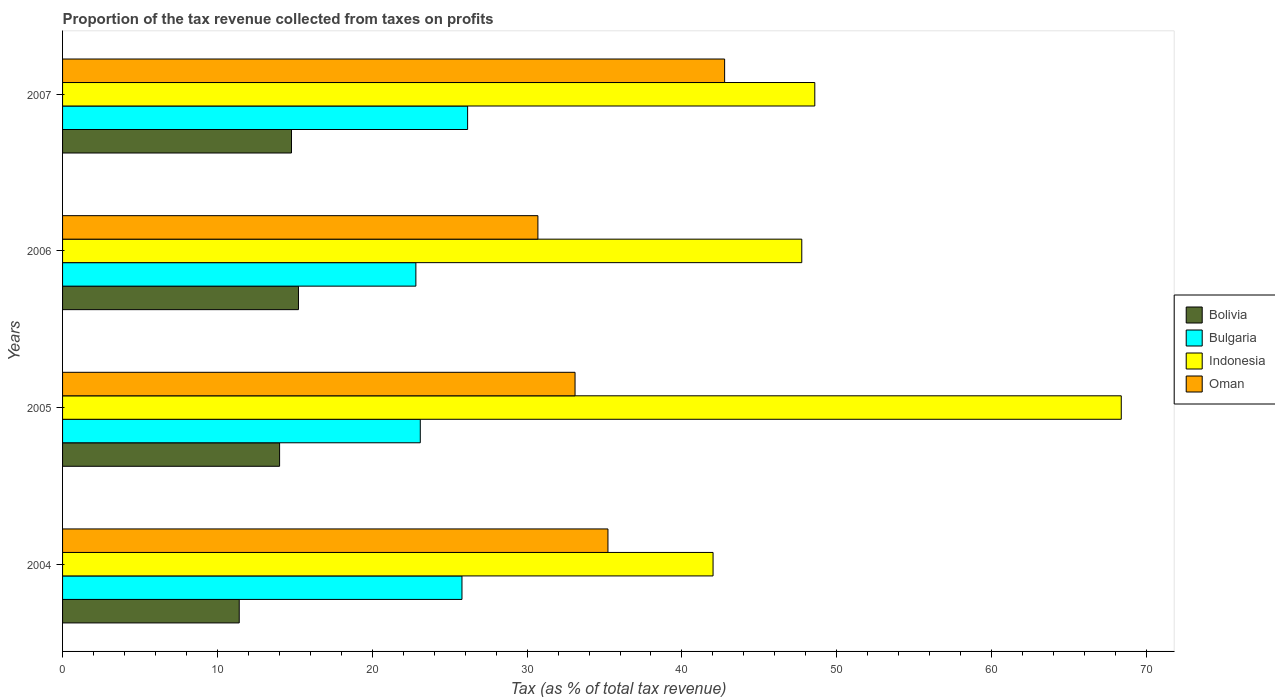How many different coloured bars are there?
Provide a short and direct response. 4. How many groups of bars are there?
Provide a succinct answer. 4. Are the number of bars per tick equal to the number of legend labels?
Ensure brevity in your answer.  Yes. Are the number of bars on each tick of the Y-axis equal?
Offer a terse response. Yes. What is the label of the 4th group of bars from the top?
Keep it short and to the point. 2004. In how many cases, is the number of bars for a given year not equal to the number of legend labels?
Ensure brevity in your answer.  0. What is the proportion of the tax revenue collected in Bolivia in 2006?
Offer a very short reply. 15.23. Across all years, what is the maximum proportion of the tax revenue collected in Oman?
Offer a very short reply. 42.76. Across all years, what is the minimum proportion of the tax revenue collected in Oman?
Your response must be concise. 30.7. In which year was the proportion of the tax revenue collected in Bulgaria maximum?
Provide a succinct answer. 2007. What is the total proportion of the tax revenue collected in Bulgaria in the graph?
Provide a short and direct response. 97.87. What is the difference between the proportion of the tax revenue collected in Bulgaria in 2004 and that in 2007?
Your answer should be compact. -0.36. What is the difference between the proportion of the tax revenue collected in Bulgaria in 2006 and the proportion of the tax revenue collected in Oman in 2005?
Keep it short and to the point. -10.28. What is the average proportion of the tax revenue collected in Bolivia per year?
Keep it short and to the point. 13.86. In the year 2007, what is the difference between the proportion of the tax revenue collected in Oman and proportion of the tax revenue collected in Bulgaria?
Ensure brevity in your answer.  16.6. In how many years, is the proportion of the tax revenue collected in Bolivia greater than 60 %?
Keep it short and to the point. 0. What is the ratio of the proportion of the tax revenue collected in Bolivia in 2005 to that in 2007?
Provide a succinct answer. 0.95. Is the difference between the proportion of the tax revenue collected in Oman in 2004 and 2006 greater than the difference between the proportion of the tax revenue collected in Bulgaria in 2004 and 2006?
Give a very brief answer. Yes. What is the difference between the highest and the second highest proportion of the tax revenue collected in Oman?
Offer a very short reply. 7.53. What is the difference between the highest and the lowest proportion of the tax revenue collected in Indonesia?
Offer a terse response. 26.36. Is the sum of the proportion of the tax revenue collected in Indonesia in 2004 and 2007 greater than the maximum proportion of the tax revenue collected in Bulgaria across all years?
Your response must be concise. Yes. What does the 1st bar from the top in 2005 represents?
Offer a terse response. Oman. What does the 3rd bar from the bottom in 2006 represents?
Offer a terse response. Indonesia. Are all the bars in the graph horizontal?
Provide a short and direct response. Yes. How many years are there in the graph?
Provide a succinct answer. 4. Does the graph contain any zero values?
Your answer should be compact. No. How many legend labels are there?
Make the answer very short. 4. What is the title of the graph?
Offer a terse response. Proportion of the tax revenue collected from taxes on profits. Does "Bangladesh" appear as one of the legend labels in the graph?
Ensure brevity in your answer.  No. What is the label or title of the X-axis?
Ensure brevity in your answer.  Tax (as % of total tax revenue). What is the label or title of the Y-axis?
Ensure brevity in your answer.  Years. What is the Tax (as % of total tax revenue) in Bolivia in 2004?
Keep it short and to the point. 11.41. What is the Tax (as % of total tax revenue) of Bulgaria in 2004?
Ensure brevity in your answer.  25.79. What is the Tax (as % of total tax revenue) of Indonesia in 2004?
Make the answer very short. 42.01. What is the Tax (as % of total tax revenue) in Oman in 2004?
Ensure brevity in your answer.  35.22. What is the Tax (as % of total tax revenue) of Bolivia in 2005?
Provide a short and direct response. 14.02. What is the Tax (as % of total tax revenue) of Bulgaria in 2005?
Your answer should be very brief. 23.1. What is the Tax (as % of total tax revenue) in Indonesia in 2005?
Offer a terse response. 68.37. What is the Tax (as % of total tax revenue) in Oman in 2005?
Offer a terse response. 33.1. What is the Tax (as % of total tax revenue) of Bolivia in 2006?
Offer a very short reply. 15.23. What is the Tax (as % of total tax revenue) of Bulgaria in 2006?
Offer a very short reply. 22.82. What is the Tax (as % of total tax revenue) in Indonesia in 2006?
Provide a succinct answer. 47.74. What is the Tax (as % of total tax revenue) of Oman in 2006?
Your response must be concise. 30.7. What is the Tax (as % of total tax revenue) of Bolivia in 2007?
Provide a short and direct response. 14.78. What is the Tax (as % of total tax revenue) in Bulgaria in 2007?
Keep it short and to the point. 26.16. What is the Tax (as % of total tax revenue) of Indonesia in 2007?
Offer a terse response. 48.58. What is the Tax (as % of total tax revenue) in Oman in 2007?
Keep it short and to the point. 42.76. Across all years, what is the maximum Tax (as % of total tax revenue) in Bolivia?
Keep it short and to the point. 15.23. Across all years, what is the maximum Tax (as % of total tax revenue) in Bulgaria?
Your answer should be very brief. 26.16. Across all years, what is the maximum Tax (as % of total tax revenue) of Indonesia?
Keep it short and to the point. 68.37. Across all years, what is the maximum Tax (as % of total tax revenue) in Oman?
Provide a succinct answer. 42.76. Across all years, what is the minimum Tax (as % of total tax revenue) in Bolivia?
Keep it short and to the point. 11.41. Across all years, what is the minimum Tax (as % of total tax revenue) of Bulgaria?
Make the answer very short. 22.82. Across all years, what is the minimum Tax (as % of total tax revenue) of Indonesia?
Offer a terse response. 42.01. Across all years, what is the minimum Tax (as % of total tax revenue) in Oman?
Give a very brief answer. 30.7. What is the total Tax (as % of total tax revenue) of Bolivia in the graph?
Provide a short and direct response. 55.44. What is the total Tax (as % of total tax revenue) in Bulgaria in the graph?
Provide a short and direct response. 97.87. What is the total Tax (as % of total tax revenue) in Indonesia in the graph?
Your answer should be very brief. 206.7. What is the total Tax (as % of total tax revenue) of Oman in the graph?
Ensure brevity in your answer.  141.77. What is the difference between the Tax (as % of total tax revenue) of Bolivia in 2004 and that in 2005?
Your response must be concise. -2.61. What is the difference between the Tax (as % of total tax revenue) in Bulgaria in 2004 and that in 2005?
Your response must be concise. 2.69. What is the difference between the Tax (as % of total tax revenue) of Indonesia in 2004 and that in 2005?
Offer a very short reply. -26.36. What is the difference between the Tax (as % of total tax revenue) in Oman in 2004 and that in 2005?
Provide a succinct answer. 2.13. What is the difference between the Tax (as % of total tax revenue) of Bolivia in 2004 and that in 2006?
Your answer should be compact. -3.83. What is the difference between the Tax (as % of total tax revenue) in Bulgaria in 2004 and that in 2006?
Provide a succinct answer. 2.98. What is the difference between the Tax (as % of total tax revenue) in Indonesia in 2004 and that in 2006?
Your answer should be compact. -5.73. What is the difference between the Tax (as % of total tax revenue) of Oman in 2004 and that in 2006?
Make the answer very short. 4.52. What is the difference between the Tax (as % of total tax revenue) in Bolivia in 2004 and that in 2007?
Provide a succinct answer. -3.37. What is the difference between the Tax (as % of total tax revenue) in Bulgaria in 2004 and that in 2007?
Provide a succinct answer. -0.36. What is the difference between the Tax (as % of total tax revenue) of Indonesia in 2004 and that in 2007?
Your answer should be compact. -6.57. What is the difference between the Tax (as % of total tax revenue) in Oman in 2004 and that in 2007?
Give a very brief answer. -7.53. What is the difference between the Tax (as % of total tax revenue) in Bolivia in 2005 and that in 2006?
Give a very brief answer. -1.22. What is the difference between the Tax (as % of total tax revenue) of Bulgaria in 2005 and that in 2006?
Give a very brief answer. 0.28. What is the difference between the Tax (as % of total tax revenue) in Indonesia in 2005 and that in 2006?
Provide a short and direct response. 20.63. What is the difference between the Tax (as % of total tax revenue) of Oman in 2005 and that in 2006?
Your response must be concise. 2.4. What is the difference between the Tax (as % of total tax revenue) of Bolivia in 2005 and that in 2007?
Offer a very short reply. -0.77. What is the difference between the Tax (as % of total tax revenue) in Bulgaria in 2005 and that in 2007?
Make the answer very short. -3.06. What is the difference between the Tax (as % of total tax revenue) in Indonesia in 2005 and that in 2007?
Provide a short and direct response. 19.79. What is the difference between the Tax (as % of total tax revenue) of Oman in 2005 and that in 2007?
Provide a succinct answer. -9.66. What is the difference between the Tax (as % of total tax revenue) in Bolivia in 2006 and that in 2007?
Make the answer very short. 0.45. What is the difference between the Tax (as % of total tax revenue) in Bulgaria in 2006 and that in 2007?
Your response must be concise. -3.34. What is the difference between the Tax (as % of total tax revenue) of Indonesia in 2006 and that in 2007?
Your answer should be compact. -0.84. What is the difference between the Tax (as % of total tax revenue) in Oman in 2006 and that in 2007?
Offer a very short reply. -12.06. What is the difference between the Tax (as % of total tax revenue) in Bolivia in 2004 and the Tax (as % of total tax revenue) in Bulgaria in 2005?
Your response must be concise. -11.69. What is the difference between the Tax (as % of total tax revenue) in Bolivia in 2004 and the Tax (as % of total tax revenue) in Indonesia in 2005?
Your answer should be compact. -56.96. What is the difference between the Tax (as % of total tax revenue) in Bolivia in 2004 and the Tax (as % of total tax revenue) in Oman in 2005?
Keep it short and to the point. -21.69. What is the difference between the Tax (as % of total tax revenue) of Bulgaria in 2004 and the Tax (as % of total tax revenue) of Indonesia in 2005?
Make the answer very short. -42.58. What is the difference between the Tax (as % of total tax revenue) in Bulgaria in 2004 and the Tax (as % of total tax revenue) in Oman in 2005?
Give a very brief answer. -7.3. What is the difference between the Tax (as % of total tax revenue) in Indonesia in 2004 and the Tax (as % of total tax revenue) in Oman in 2005?
Give a very brief answer. 8.91. What is the difference between the Tax (as % of total tax revenue) in Bolivia in 2004 and the Tax (as % of total tax revenue) in Bulgaria in 2006?
Ensure brevity in your answer.  -11.41. What is the difference between the Tax (as % of total tax revenue) in Bolivia in 2004 and the Tax (as % of total tax revenue) in Indonesia in 2006?
Offer a terse response. -36.33. What is the difference between the Tax (as % of total tax revenue) in Bolivia in 2004 and the Tax (as % of total tax revenue) in Oman in 2006?
Ensure brevity in your answer.  -19.29. What is the difference between the Tax (as % of total tax revenue) of Bulgaria in 2004 and the Tax (as % of total tax revenue) of Indonesia in 2006?
Make the answer very short. -21.95. What is the difference between the Tax (as % of total tax revenue) of Bulgaria in 2004 and the Tax (as % of total tax revenue) of Oman in 2006?
Your answer should be compact. -4.9. What is the difference between the Tax (as % of total tax revenue) in Indonesia in 2004 and the Tax (as % of total tax revenue) in Oman in 2006?
Your answer should be compact. 11.31. What is the difference between the Tax (as % of total tax revenue) in Bolivia in 2004 and the Tax (as % of total tax revenue) in Bulgaria in 2007?
Make the answer very short. -14.75. What is the difference between the Tax (as % of total tax revenue) of Bolivia in 2004 and the Tax (as % of total tax revenue) of Indonesia in 2007?
Provide a short and direct response. -37.17. What is the difference between the Tax (as % of total tax revenue) of Bolivia in 2004 and the Tax (as % of total tax revenue) of Oman in 2007?
Ensure brevity in your answer.  -31.35. What is the difference between the Tax (as % of total tax revenue) in Bulgaria in 2004 and the Tax (as % of total tax revenue) in Indonesia in 2007?
Give a very brief answer. -22.79. What is the difference between the Tax (as % of total tax revenue) of Bulgaria in 2004 and the Tax (as % of total tax revenue) of Oman in 2007?
Your response must be concise. -16.96. What is the difference between the Tax (as % of total tax revenue) in Indonesia in 2004 and the Tax (as % of total tax revenue) in Oman in 2007?
Provide a succinct answer. -0.75. What is the difference between the Tax (as % of total tax revenue) of Bolivia in 2005 and the Tax (as % of total tax revenue) of Bulgaria in 2006?
Your response must be concise. -8.8. What is the difference between the Tax (as % of total tax revenue) in Bolivia in 2005 and the Tax (as % of total tax revenue) in Indonesia in 2006?
Your answer should be very brief. -33.72. What is the difference between the Tax (as % of total tax revenue) in Bolivia in 2005 and the Tax (as % of total tax revenue) in Oman in 2006?
Keep it short and to the point. -16.68. What is the difference between the Tax (as % of total tax revenue) of Bulgaria in 2005 and the Tax (as % of total tax revenue) of Indonesia in 2006?
Make the answer very short. -24.64. What is the difference between the Tax (as % of total tax revenue) of Bulgaria in 2005 and the Tax (as % of total tax revenue) of Oman in 2006?
Ensure brevity in your answer.  -7.6. What is the difference between the Tax (as % of total tax revenue) of Indonesia in 2005 and the Tax (as % of total tax revenue) of Oman in 2006?
Your answer should be very brief. 37.67. What is the difference between the Tax (as % of total tax revenue) of Bolivia in 2005 and the Tax (as % of total tax revenue) of Bulgaria in 2007?
Give a very brief answer. -12.14. What is the difference between the Tax (as % of total tax revenue) in Bolivia in 2005 and the Tax (as % of total tax revenue) in Indonesia in 2007?
Give a very brief answer. -34.56. What is the difference between the Tax (as % of total tax revenue) in Bolivia in 2005 and the Tax (as % of total tax revenue) in Oman in 2007?
Your answer should be compact. -28.74. What is the difference between the Tax (as % of total tax revenue) in Bulgaria in 2005 and the Tax (as % of total tax revenue) in Indonesia in 2007?
Give a very brief answer. -25.48. What is the difference between the Tax (as % of total tax revenue) in Bulgaria in 2005 and the Tax (as % of total tax revenue) in Oman in 2007?
Give a very brief answer. -19.65. What is the difference between the Tax (as % of total tax revenue) of Indonesia in 2005 and the Tax (as % of total tax revenue) of Oman in 2007?
Your answer should be compact. 25.61. What is the difference between the Tax (as % of total tax revenue) in Bolivia in 2006 and the Tax (as % of total tax revenue) in Bulgaria in 2007?
Your answer should be very brief. -10.92. What is the difference between the Tax (as % of total tax revenue) of Bolivia in 2006 and the Tax (as % of total tax revenue) of Indonesia in 2007?
Your response must be concise. -33.34. What is the difference between the Tax (as % of total tax revenue) of Bolivia in 2006 and the Tax (as % of total tax revenue) of Oman in 2007?
Ensure brevity in your answer.  -27.52. What is the difference between the Tax (as % of total tax revenue) of Bulgaria in 2006 and the Tax (as % of total tax revenue) of Indonesia in 2007?
Ensure brevity in your answer.  -25.76. What is the difference between the Tax (as % of total tax revenue) in Bulgaria in 2006 and the Tax (as % of total tax revenue) in Oman in 2007?
Offer a terse response. -19.94. What is the difference between the Tax (as % of total tax revenue) of Indonesia in 2006 and the Tax (as % of total tax revenue) of Oman in 2007?
Your response must be concise. 4.98. What is the average Tax (as % of total tax revenue) of Bolivia per year?
Give a very brief answer. 13.86. What is the average Tax (as % of total tax revenue) in Bulgaria per year?
Provide a succinct answer. 24.47. What is the average Tax (as % of total tax revenue) of Indonesia per year?
Offer a terse response. 51.67. What is the average Tax (as % of total tax revenue) in Oman per year?
Your answer should be compact. 35.44. In the year 2004, what is the difference between the Tax (as % of total tax revenue) in Bolivia and Tax (as % of total tax revenue) in Bulgaria?
Your response must be concise. -14.38. In the year 2004, what is the difference between the Tax (as % of total tax revenue) in Bolivia and Tax (as % of total tax revenue) in Indonesia?
Your answer should be compact. -30.6. In the year 2004, what is the difference between the Tax (as % of total tax revenue) of Bolivia and Tax (as % of total tax revenue) of Oman?
Give a very brief answer. -23.81. In the year 2004, what is the difference between the Tax (as % of total tax revenue) of Bulgaria and Tax (as % of total tax revenue) of Indonesia?
Keep it short and to the point. -16.21. In the year 2004, what is the difference between the Tax (as % of total tax revenue) of Bulgaria and Tax (as % of total tax revenue) of Oman?
Offer a very short reply. -9.43. In the year 2004, what is the difference between the Tax (as % of total tax revenue) of Indonesia and Tax (as % of total tax revenue) of Oman?
Provide a succinct answer. 6.79. In the year 2005, what is the difference between the Tax (as % of total tax revenue) of Bolivia and Tax (as % of total tax revenue) of Bulgaria?
Your answer should be compact. -9.09. In the year 2005, what is the difference between the Tax (as % of total tax revenue) in Bolivia and Tax (as % of total tax revenue) in Indonesia?
Offer a very short reply. -54.35. In the year 2005, what is the difference between the Tax (as % of total tax revenue) of Bolivia and Tax (as % of total tax revenue) of Oman?
Offer a very short reply. -19.08. In the year 2005, what is the difference between the Tax (as % of total tax revenue) in Bulgaria and Tax (as % of total tax revenue) in Indonesia?
Provide a short and direct response. -45.27. In the year 2005, what is the difference between the Tax (as % of total tax revenue) of Bulgaria and Tax (as % of total tax revenue) of Oman?
Your answer should be compact. -9.99. In the year 2005, what is the difference between the Tax (as % of total tax revenue) of Indonesia and Tax (as % of total tax revenue) of Oman?
Offer a terse response. 35.27. In the year 2006, what is the difference between the Tax (as % of total tax revenue) of Bolivia and Tax (as % of total tax revenue) of Bulgaria?
Offer a terse response. -7.58. In the year 2006, what is the difference between the Tax (as % of total tax revenue) of Bolivia and Tax (as % of total tax revenue) of Indonesia?
Your answer should be compact. -32.5. In the year 2006, what is the difference between the Tax (as % of total tax revenue) in Bolivia and Tax (as % of total tax revenue) in Oman?
Make the answer very short. -15.46. In the year 2006, what is the difference between the Tax (as % of total tax revenue) of Bulgaria and Tax (as % of total tax revenue) of Indonesia?
Offer a very short reply. -24.92. In the year 2006, what is the difference between the Tax (as % of total tax revenue) in Bulgaria and Tax (as % of total tax revenue) in Oman?
Your answer should be very brief. -7.88. In the year 2006, what is the difference between the Tax (as % of total tax revenue) in Indonesia and Tax (as % of total tax revenue) in Oman?
Provide a short and direct response. 17.04. In the year 2007, what is the difference between the Tax (as % of total tax revenue) of Bolivia and Tax (as % of total tax revenue) of Bulgaria?
Provide a short and direct response. -11.37. In the year 2007, what is the difference between the Tax (as % of total tax revenue) in Bolivia and Tax (as % of total tax revenue) in Indonesia?
Make the answer very short. -33.79. In the year 2007, what is the difference between the Tax (as % of total tax revenue) of Bolivia and Tax (as % of total tax revenue) of Oman?
Your answer should be very brief. -27.97. In the year 2007, what is the difference between the Tax (as % of total tax revenue) of Bulgaria and Tax (as % of total tax revenue) of Indonesia?
Make the answer very short. -22.42. In the year 2007, what is the difference between the Tax (as % of total tax revenue) of Bulgaria and Tax (as % of total tax revenue) of Oman?
Ensure brevity in your answer.  -16.6. In the year 2007, what is the difference between the Tax (as % of total tax revenue) of Indonesia and Tax (as % of total tax revenue) of Oman?
Give a very brief answer. 5.82. What is the ratio of the Tax (as % of total tax revenue) in Bolivia in 2004 to that in 2005?
Your response must be concise. 0.81. What is the ratio of the Tax (as % of total tax revenue) of Bulgaria in 2004 to that in 2005?
Your answer should be very brief. 1.12. What is the ratio of the Tax (as % of total tax revenue) of Indonesia in 2004 to that in 2005?
Offer a terse response. 0.61. What is the ratio of the Tax (as % of total tax revenue) of Oman in 2004 to that in 2005?
Your answer should be very brief. 1.06. What is the ratio of the Tax (as % of total tax revenue) of Bolivia in 2004 to that in 2006?
Ensure brevity in your answer.  0.75. What is the ratio of the Tax (as % of total tax revenue) of Bulgaria in 2004 to that in 2006?
Offer a very short reply. 1.13. What is the ratio of the Tax (as % of total tax revenue) in Oman in 2004 to that in 2006?
Provide a succinct answer. 1.15. What is the ratio of the Tax (as % of total tax revenue) in Bolivia in 2004 to that in 2007?
Keep it short and to the point. 0.77. What is the ratio of the Tax (as % of total tax revenue) in Bulgaria in 2004 to that in 2007?
Make the answer very short. 0.99. What is the ratio of the Tax (as % of total tax revenue) of Indonesia in 2004 to that in 2007?
Your response must be concise. 0.86. What is the ratio of the Tax (as % of total tax revenue) in Oman in 2004 to that in 2007?
Offer a terse response. 0.82. What is the ratio of the Tax (as % of total tax revenue) of Bolivia in 2005 to that in 2006?
Ensure brevity in your answer.  0.92. What is the ratio of the Tax (as % of total tax revenue) of Bulgaria in 2005 to that in 2006?
Give a very brief answer. 1.01. What is the ratio of the Tax (as % of total tax revenue) in Indonesia in 2005 to that in 2006?
Your answer should be very brief. 1.43. What is the ratio of the Tax (as % of total tax revenue) of Oman in 2005 to that in 2006?
Ensure brevity in your answer.  1.08. What is the ratio of the Tax (as % of total tax revenue) of Bolivia in 2005 to that in 2007?
Your answer should be compact. 0.95. What is the ratio of the Tax (as % of total tax revenue) of Bulgaria in 2005 to that in 2007?
Your answer should be very brief. 0.88. What is the ratio of the Tax (as % of total tax revenue) in Indonesia in 2005 to that in 2007?
Give a very brief answer. 1.41. What is the ratio of the Tax (as % of total tax revenue) of Oman in 2005 to that in 2007?
Make the answer very short. 0.77. What is the ratio of the Tax (as % of total tax revenue) of Bolivia in 2006 to that in 2007?
Offer a very short reply. 1.03. What is the ratio of the Tax (as % of total tax revenue) of Bulgaria in 2006 to that in 2007?
Offer a terse response. 0.87. What is the ratio of the Tax (as % of total tax revenue) of Indonesia in 2006 to that in 2007?
Keep it short and to the point. 0.98. What is the ratio of the Tax (as % of total tax revenue) in Oman in 2006 to that in 2007?
Provide a succinct answer. 0.72. What is the difference between the highest and the second highest Tax (as % of total tax revenue) in Bolivia?
Provide a short and direct response. 0.45. What is the difference between the highest and the second highest Tax (as % of total tax revenue) in Bulgaria?
Offer a terse response. 0.36. What is the difference between the highest and the second highest Tax (as % of total tax revenue) of Indonesia?
Your answer should be very brief. 19.79. What is the difference between the highest and the second highest Tax (as % of total tax revenue) in Oman?
Keep it short and to the point. 7.53. What is the difference between the highest and the lowest Tax (as % of total tax revenue) in Bolivia?
Provide a succinct answer. 3.83. What is the difference between the highest and the lowest Tax (as % of total tax revenue) in Bulgaria?
Offer a terse response. 3.34. What is the difference between the highest and the lowest Tax (as % of total tax revenue) of Indonesia?
Ensure brevity in your answer.  26.36. What is the difference between the highest and the lowest Tax (as % of total tax revenue) in Oman?
Your answer should be very brief. 12.06. 